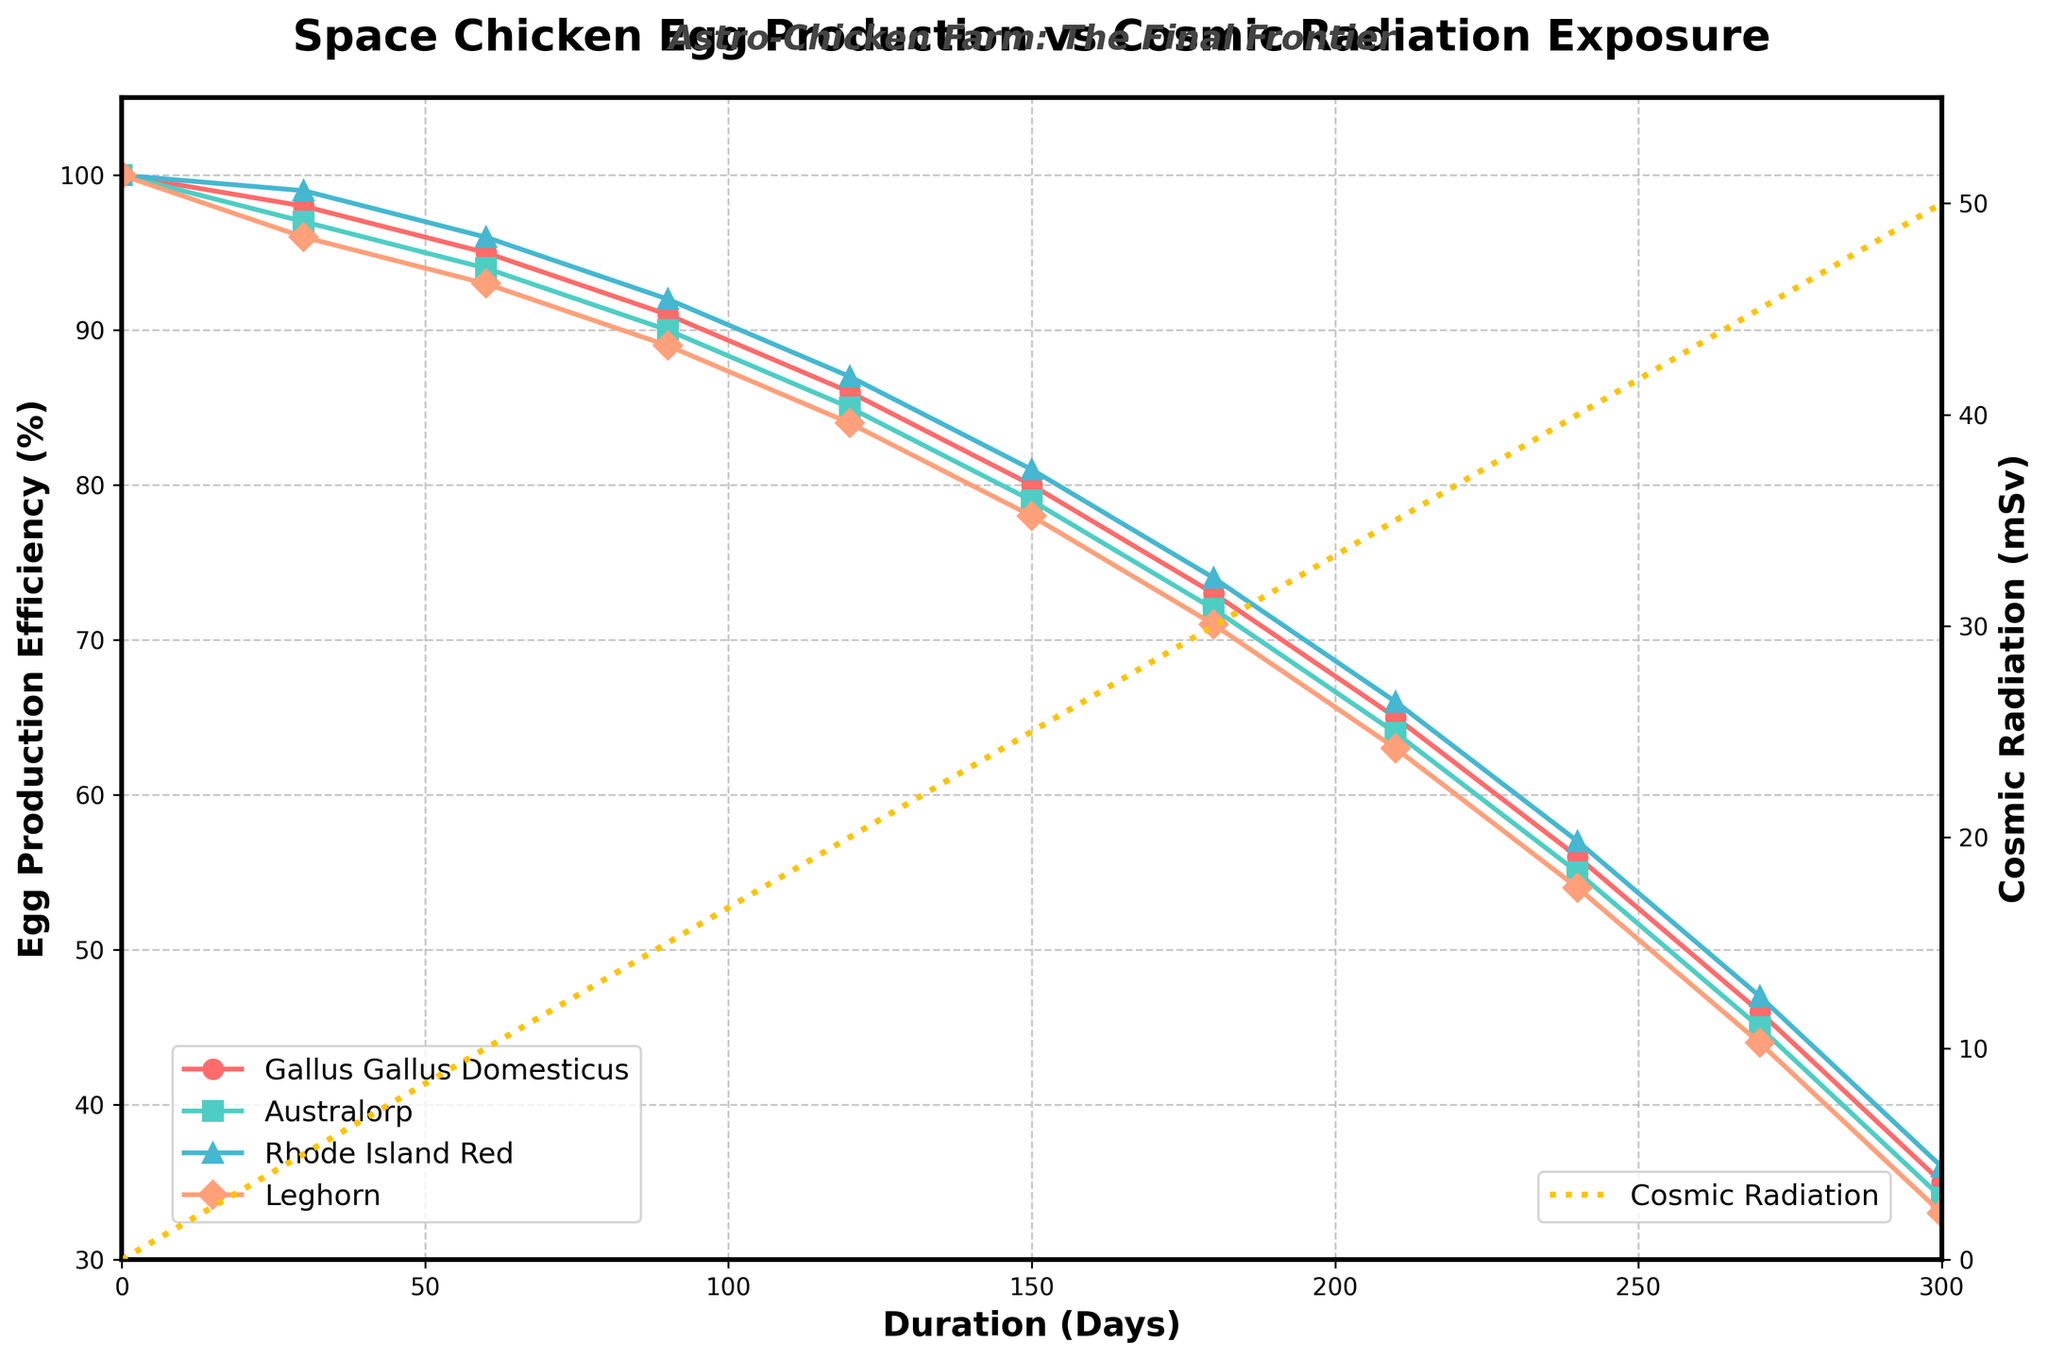Which chicken breed showed the highest egg production efficiency at the start? At the start (0 days), all chicken breeds showed 100% egg production efficiency. Since they are all equal, any breed can be correct.
Answer: Any breed At 150 days, what is the difference in egg production efficiency between the Gallus Gallus Domesticus and Rhode Island Red breeds? The efficiency for Gallus Gallus Domesticus is 80%, and for Rhode Island Red it is 81%. The difference is 81% - 80% = 1%.
Answer: 1% What is the trend of cosmic radiation over time? From the start (0 days) to the end (300 days), the cosmic radiation steadily increases from 0 mSv to 50 mSv with time.
Answer: Steadily increasing Which chicken breed's egg production efficiency decreased the fastest over the 300 days? By visually inspecting the slopes of the lines, the Leghorn breed's line appears to have the steepest overall decline from 100% to 33%.
Answer: Leghorn What is the egg production efficiency of the Australorp breed at 90 days? At 90 days, following the line for the Australorp breed, the efficiency is at 90%.
Answer: 90% Compare the egg production efficiency of Gallus Gallus Domesticus and Leghorn at 240 days. At 240 days, Gallus Gallus Domesticus has an efficiency of 56%, whereas Leghorn has an efficiency of 54%. The Gallus Gallus Domesticus is slightly higher.
Answer: Gallus Gallus Domesticus What is the average egg production efficiency of the Rhode Island Red breed at 0 and 300 days? The efficiencies at 0 days and 300 days are 100% and 36% respectively. The average is (100 + 36) / 2 = 68%.
Answer: 68% Which breed showed a consistent decrease without any sudden changes over the period? Examining the lines for all breeds, the Rhode Island Red exhibits a consistent and smooth drop in egg production efficiency over time.
Answer: Rhode Island Red At what day is the eggs production efficiency approximately equal for the Gallus Gallus Domesticus and the Leghorn breeds? By checking the intersection of the two lines, Gallus Gallus Domesticus and Leghorn intersect around 270 days where their efficiencies are close to 46% and 44%, respectively.
Answer: Around 270 days What is the visual difference in plot markers used for the Rhode Island Red and Leghorn breeds? The Rhode Island Red uses triangle markers (^) while the Leghorn uses diamond markers (D).
Answer: Triangles and Diamonds 